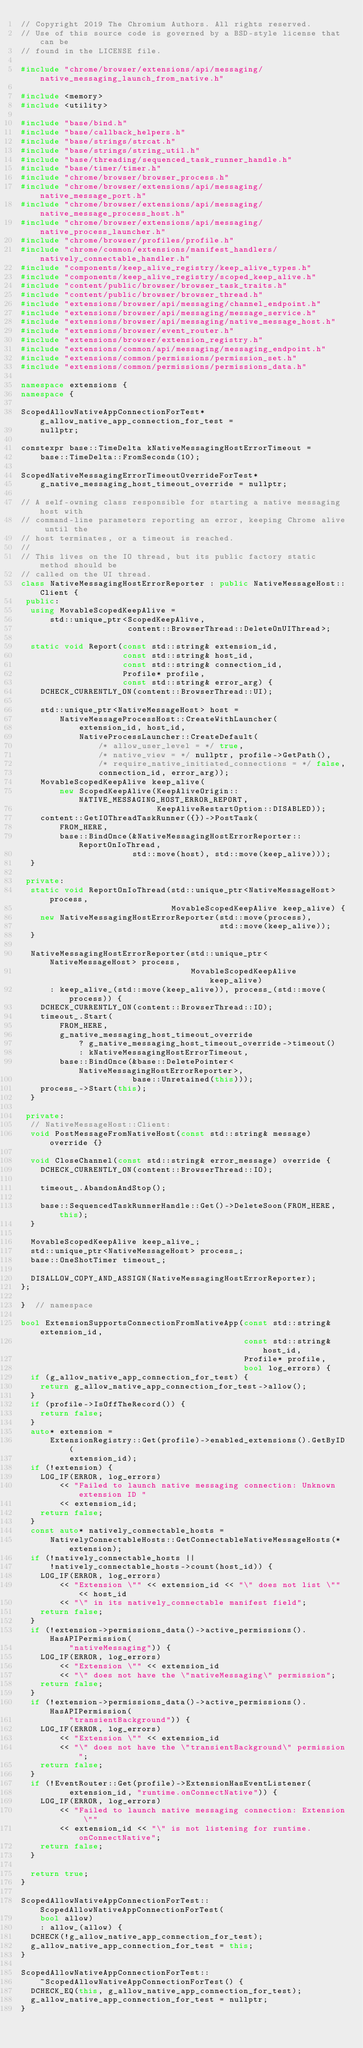<code> <loc_0><loc_0><loc_500><loc_500><_C++_>// Copyright 2019 The Chromium Authors. All rights reserved.
// Use of this source code is governed by a BSD-style license that can be
// found in the LICENSE file.

#include "chrome/browser/extensions/api/messaging/native_messaging_launch_from_native.h"

#include <memory>
#include <utility>

#include "base/bind.h"
#include "base/callback_helpers.h"
#include "base/strings/strcat.h"
#include "base/strings/string_util.h"
#include "base/threading/sequenced_task_runner_handle.h"
#include "base/timer/timer.h"
#include "chrome/browser/browser_process.h"
#include "chrome/browser/extensions/api/messaging/native_message_port.h"
#include "chrome/browser/extensions/api/messaging/native_message_process_host.h"
#include "chrome/browser/extensions/api/messaging/native_process_launcher.h"
#include "chrome/browser/profiles/profile.h"
#include "chrome/common/extensions/manifest_handlers/natively_connectable_handler.h"
#include "components/keep_alive_registry/keep_alive_types.h"
#include "components/keep_alive_registry/scoped_keep_alive.h"
#include "content/public/browser/browser_task_traits.h"
#include "content/public/browser/browser_thread.h"
#include "extensions/browser/api/messaging/channel_endpoint.h"
#include "extensions/browser/api/messaging/message_service.h"
#include "extensions/browser/api/messaging/native_message_host.h"
#include "extensions/browser/event_router.h"
#include "extensions/browser/extension_registry.h"
#include "extensions/common/api/messaging/messaging_endpoint.h"
#include "extensions/common/permissions/permission_set.h"
#include "extensions/common/permissions/permissions_data.h"

namespace extensions {
namespace {

ScopedAllowNativeAppConnectionForTest* g_allow_native_app_connection_for_test =
    nullptr;

constexpr base::TimeDelta kNativeMessagingHostErrorTimeout =
    base::TimeDelta::FromSeconds(10);

ScopedNativeMessagingErrorTimeoutOverrideForTest*
    g_native_messaging_host_timeout_override = nullptr;

// A self-owning class responsible for starting a native messaging host with
// command-line parameters reporting an error, keeping Chrome alive until the
// host terminates, or a timeout is reached.
//
// This lives on the IO thread, but its public factory static method should be
// called on the UI thread.
class NativeMessagingHostErrorReporter : public NativeMessageHost::Client {
 public:
  using MovableScopedKeepAlive =
      std::unique_ptr<ScopedKeepAlive,
                      content::BrowserThread::DeleteOnUIThread>;

  static void Report(const std::string& extension_id,
                     const std::string& host_id,
                     const std::string& connection_id,
                     Profile* profile,
                     const std::string& error_arg) {
    DCHECK_CURRENTLY_ON(content::BrowserThread::UI);

    std::unique_ptr<NativeMessageHost> host =
        NativeMessageProcessHost::CreateWithLauncher(
            extension_id, host_id,
            NativeProcessLauncher::CreateDefault(
                /* allow_user_level = */ true,
                /* native_view = */ nullptr, profile->GetPath(),
                /* require_native_initiated_connections = */ false,
                connection_id, error_arg));
    MovableScopedKeepAlive keep_alive(
        new ScopedKeepAlive(KeepAliveOrigin::NATIVE_MESSAGING_HOST_ERROR_REPORT,
                            KeepAliveRestartOption::DISABLED));
    content::GetIOThreadTaskRunner({})->PostTask(
        FROM_HERE,
        base::BindOnce(&NativeMessagingHostErrorReporter::ReportOnIoThread,
                       std::move(host), std::move(keep_alive)));
  }

 private:
  static void ReportOnIoThread(std::unique_ptr<NativeMessageHost> process,
                               MovableScopedKeepAlive keep_alive) {
    new NativeMessagingHostErrorReporter(std::move(process),
                                         std::move(keep_alive));
  }

  NativeMessagingHostErrorReporter(std::unique_ptr<NativeMessageHost> process,
                                   MovableScopedKeepAlive keep_alive)
      : keep_alive_(std::move(keep_alive)), process_(std::move(process)) {
    DCHECK_CURRENTLY_ON(content::BrowserThread::IO);
    timeout_.Start(
        FROM_HERE,
        g_native_messaging_host_timeout_override
            ? g_native_messaging_host_timeout_override->timeout()
            : kNativeMessagingHostErrorTimeout,
        base::BindOnce(&base::DeletePointer<NativeMessagingHostErrorReporter>,
                       base::Unretained(this)));
    process_->Start(this);
  }

 private:
  // NativeMessageHost::Client:
  void PostMessageFromNativeHost(const std::string& message) override {}

  void CloseChannel(const std::string& error_message) override {
    DCHECK_CURRENTLY_ON(content::BrowserThread::IO);

    timeout_.AbandonAndStop();

    base::SequencedTaskRunnerHandle::Get()->DeleteSoon(FROM_HERE, this);
  }

  MovableScopedKeepAlive keep_alive_;
  std::unique_ptr<NativeMessageHost> process_;
  base::OneShotTimer timeout_;

  DISALLOW_COPY_AND_ASSIGN(NativeMessagingHostErrorReporter);
};

}  // namespace

bool ExtensionSupportsConnectionFromNativeApp(const std::string& extension_id,
                                              const std::string& host_id,
                                              Profile* profile,
                                              bool log_errors) {
  if (g_allow_native_app_connection_for_test) {
    return g_allow_native_app_connection_for_test->allow();
  }
  if (profile->IsOffTheRecord()) {
    return false;
  }
  auto* extension =
      ExtensionRegistry::Get(profile)->enabled_extensions().GetByID(
          extension_id);
  if (!extension) {
    LOG_IF(ERROR, log_errors)
        << "Failed to launch native messaging connection: Unknown extension ID "
        << extension_id;
    return false;
  }
  const auto* natively_connectable_hosts =
      NativelyConnectableHosts::GetConnectableNativeMessageHosts(*extension);
  if (!natively_connectable_hosts ||
      !natively_connectable_hosts->count(host_id)) {
    LOG_IF(ERROR, log_errors)
        << "Extension \"" << extension_id << "\" does not list \"" << host_id
        << "\" in its natively_connectable manifest field";
    return false;
  }
  if (!extension->permissions_data()->active_permissions().HasAPIPermission(
          "nativeMessaging")) {
    LOG_IF(ERROR, log_errors)
        << "Extension \"" << extension_id
        << "\" does not have the \"nativeMessaging\" permission";
    return false;
  }
  if (!extension->permissions_data()->active_permissions().HasAPIPermission(
          "transientBackground")) {
    LOG_IF(ERROR, log_errors)
        << "Extension \"" << extension_id
        << "\" does not have the \"transientBackground\" permission";
    return false;
  }
  if (!EventRouter::Get(profile)->ExtensionHasEventListener(
          extension_id, "runtime.onConnectNative")) {
    LOG_IF(ERROR, log_errors)
        << "Failed to launch native messaging connection: Extension \""
        << extension_id << "\" is not listening for runtime.onConnectNative";
    return false;
  }

  return true;
}

ScopedAllowNativeAppConnectionForTest::ScopedAllowNativeAppConnectionForTest(
    bool allow)
    : allow_(allow) {
  DCHECK(!g_allow_native_app_connection_for_test);
  g_allow_native_app_connection_for_test = this;
}

ScopedAllowNativeAppConnectionForTest::
    ~ScopedAllowNativeAppConnectionForTest() {
  DCHECK_EQ(this, g_allow_native_app_connection_for_test);
  g_allow_native_app_connection_for_test = nullptr;
}
</code> 